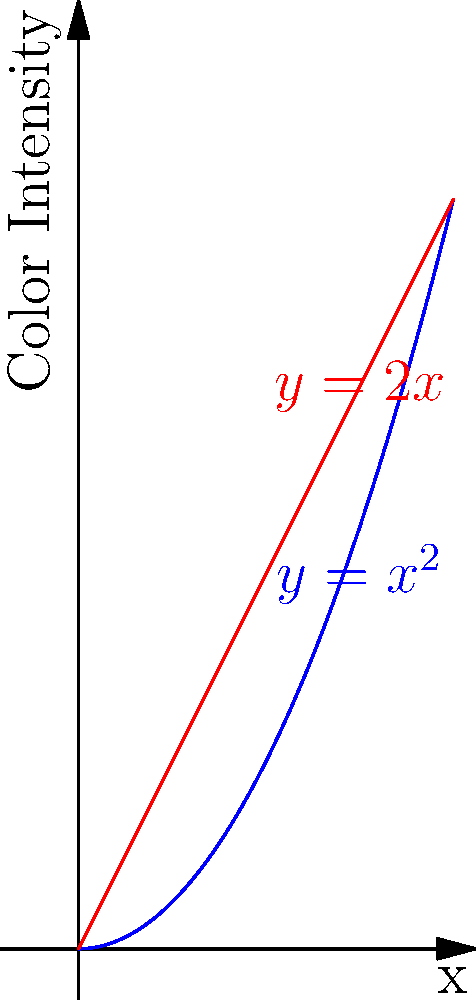Consider two paint gradients represented by the functions $f(x)=x^2$ (blue) and $g(x)=2x$ (red), where $x$ is the distance along the canvas and $y$ is the color intensity. At what point do these gradients have the same rate of change in color intensity? To find the point where the gradients have the same rate of change, we need to follow these steps:

1) First, we need to find the rate of change (derivative) for each function:
   For $f(x)=x^2$, $f'(x) = 2x$
   For $g(x)=2x$, $g'(x) = 2$

2) Now, we set these derivatives equal to each other:
   $f'(x) = g'(x)$
   $2x = 2$

3) Solve for x:
   $x = 1$

4) To verify, we can substitute this x-value back into the original functions:
   $f(1) = 1^2 = 1$
   $g(1) = 2(1) = 2$

5) The point where the gradients have the same rate of change is (1, 1) for $f(x)$ and (1, 2) for $g(x)$.

This point represents where the slope of the blue curve ($x^2$) becomes equal to the constant slope of the red line (2x).
Answer: $x = 1$ 